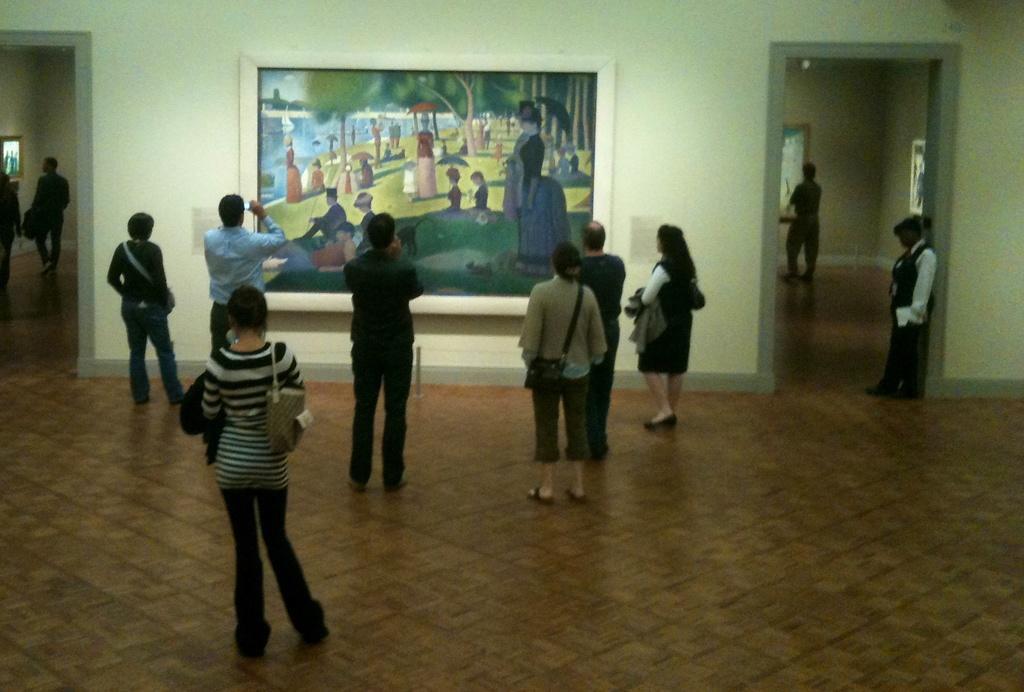Could you give a brief overview of what you see in this image? In this image, there are few people standing on the floor. I can see the photo frames, which are attached to the walls. On the left and right side of the image, there are two rooms. 